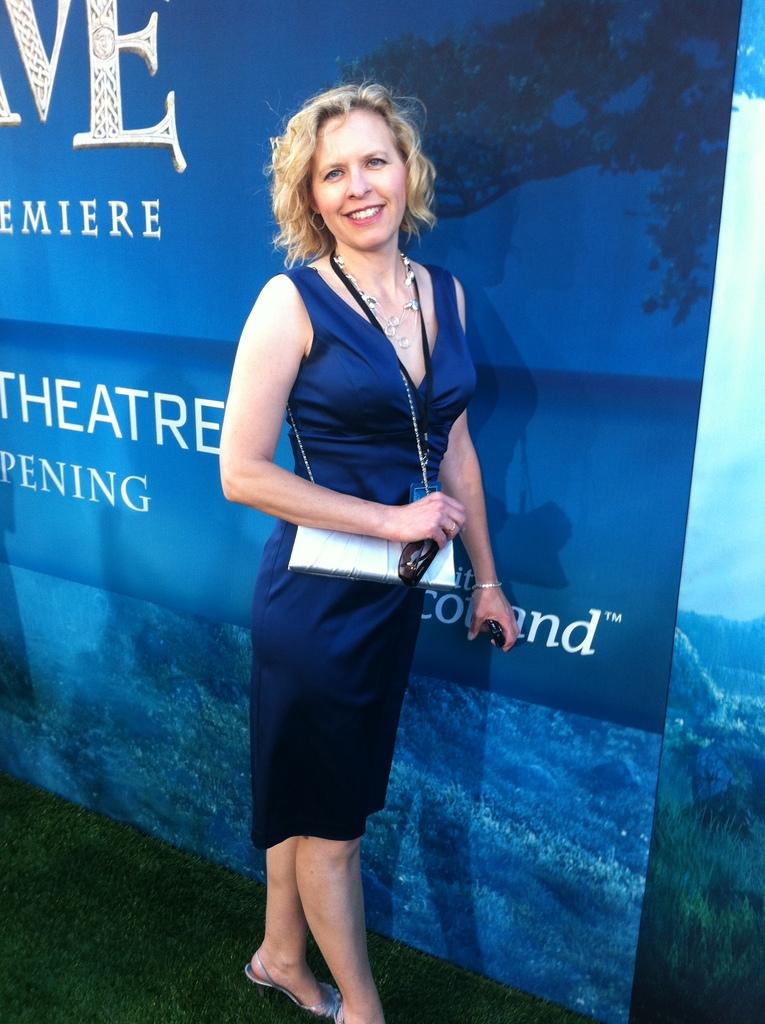Who is present in the image? There is a woman in the image. What is the woman wearing? The woman is wearing a blue dress. What is the woman doing in the image? The woman is standing and holding objects in her hand. What can be seen in the background of the image? There is a blue banner in the background of the image. What language is the woman speaking in the image? There is no indication of the language being spoken in the image, as there is no audio or text present. Can you tell me how many fingers the woman is using to hold the objects in the image? The image does not provide enough detail to determine the exact number of fingers the woman is using to hold the objects. 